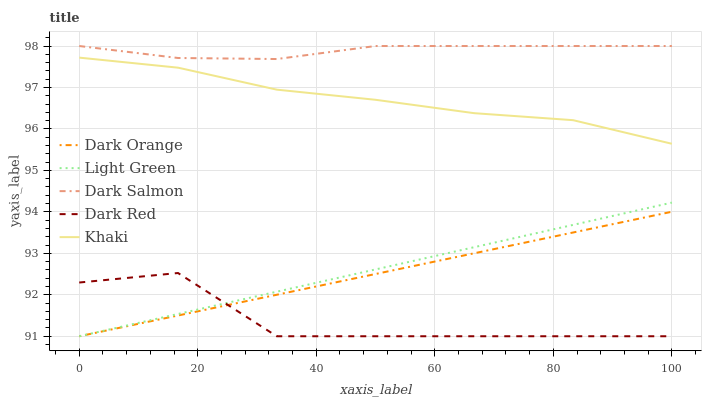Does Dark Red have the minimum area under the curve?
Answer yes or no. Yes. Does Dark Salmon have the maximum area under the curve?
Answer yes or no. Yes. Does Khaki have the minimum area under the curve?
Answer yes or no. No. Does Khaki have the maximum area under the curve?
Answer yes or no. No. Is Light Green the smoothest?
Answer yes or no. Yes. Is Dark Red the roughest?
Answer yes or no. Yes. Is Khaki the smoothest?
Answer yes or no. No. Is Khaki the roughest?
Answer yes or no. No. Does Dark Orange have the lowest value?
Answer yes or no. Yes. Does Khaki have the lowest value?
Answer yes or no. No. Does Dark Salmon have the highest value?
Answer yes or no. Yes. Does Khaki have the highest value?
Answer yes or no. No. Is Light Green less than Khaki?
Answer yes or no. Yes. Is Dark Salmon greater than Dark Orange?
Answer yes or no. Yes. Does Light Green intersect Dark Orange?
Answer yes or no. Yes. Is Light Green less than Dark Orange?
Answer yes or no. No. Is Light Green greater than Dark Orange?
Answer yes or no. No. Does Light Green intersect Khaki?
Answer yes or no. No. 